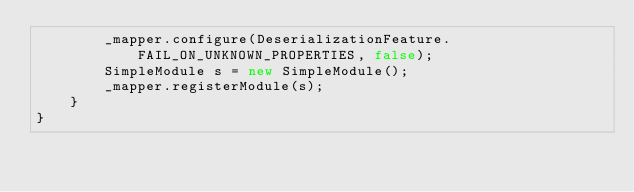<code> <loc_0><loc_0><loc_500><loc_500><_Java_>        _mapper.configure(DeserializationFeature.FAIL_ON_UNKNOWN_PROPERTIES, false);
        SimpleModule s = new SimpleModule();
        _mapper.registerModule(s);
    }
}
</code> 